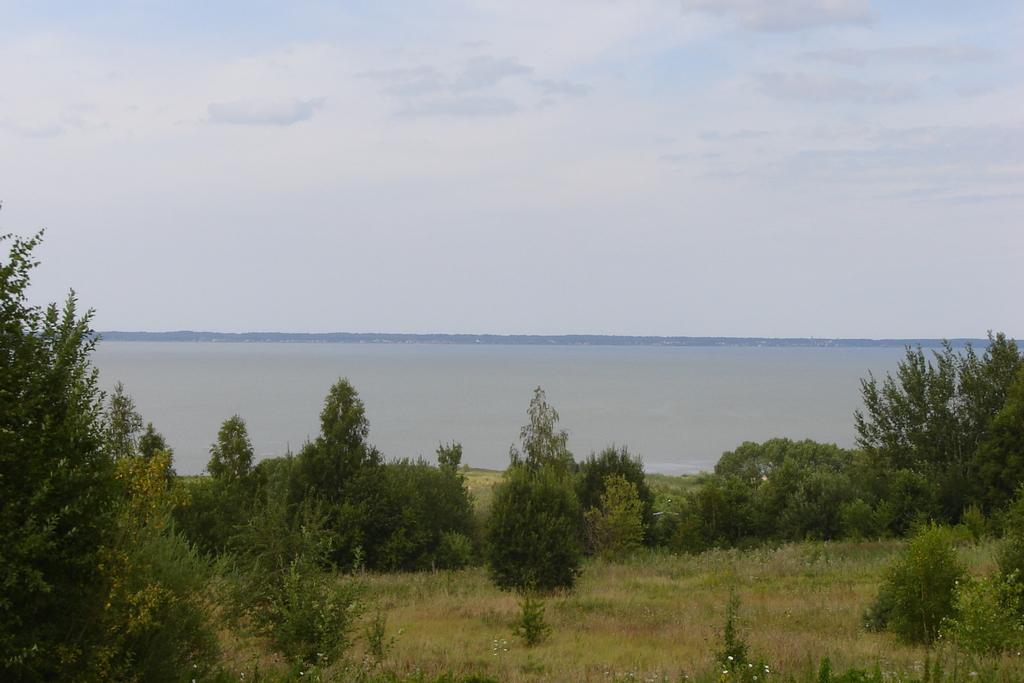What types of vegetation can be seen in the foreground of the image? There are trees and plants in the foreground of the image. What is visible in the background of the image? There is a water body in the background of the image. How would you describe the sky in the image? The sky is cloudy in the image. What type of zinc object can be seen floating on the water body in the image? There is no zinc object present in the image, and therefore no such object can be observed floating on the water body. 